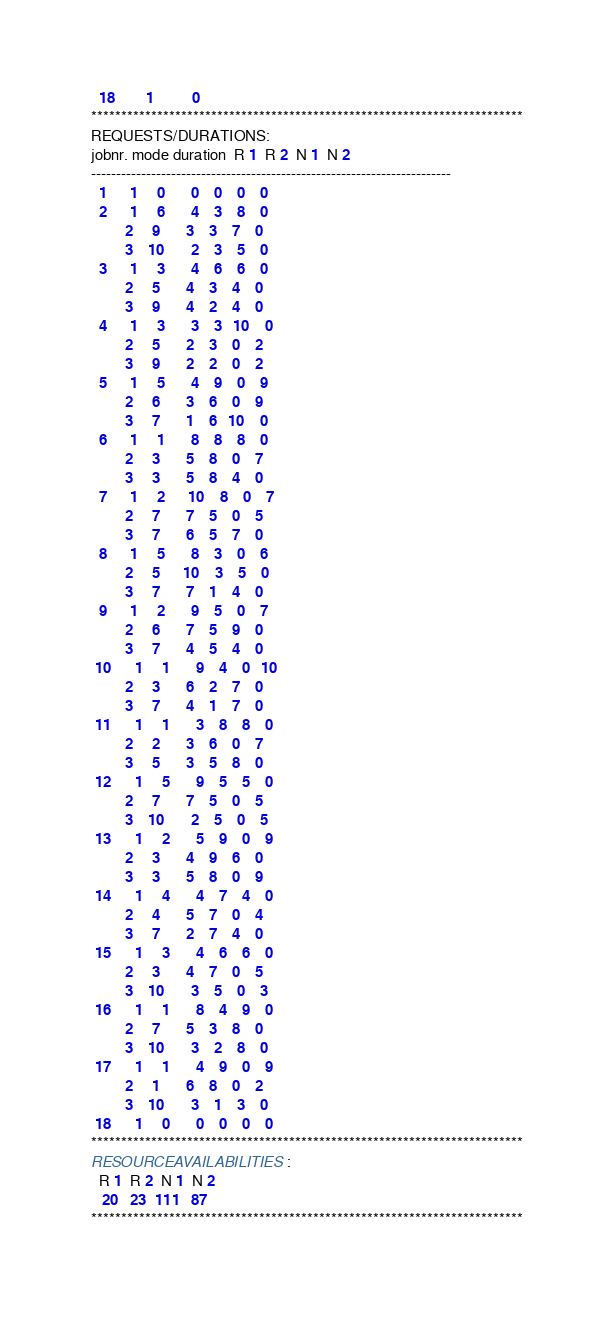Convert code to text. <code><loc_0><loc_0><loc_500><loc_500><_ObjectiveC_>  18        1          0        
************************************************************************
REQUESTS/DURATIONS:
jobnr. mode duration  R 1  R 2  N 1  N 2
------------------------------------------------------------------------
  1      1     0       0    0    0    0
  2      1     6       4    3    8    0
         2     9       3    3    7    0
         3    10       2    3    5    0
  3      1     3       4    6    6    0
         2     5       4    3    4    0
         3     9       4    2    4    0
  4      1     3       3    3   10    0
         2     5       2    3    0    2
         3     9       2    2    0    2
  5      1     5       4    9    0    9
         2     6       3    6    0    9
         3     7       1    6   10    0
  6      1     1       8    8    8    0
         2     3       5    8    0    7
         3     3       5    8    4    0
  7      1     2      10    8    0    7
         2     7       7    5    0    5
         3     7       6    5    7    0
  8      1     5       8    3    0    6
         2     5      10    3    5    0
         3     7       7    1    4    0
  9      1     2       9    5    0    7
         2     6       7    5    9    0
         3     7       4    5    4    0
 10      1     1       9    4    0   10
         2     3       6    2    7    0
         3     7       4    1    7    0
 11      1     1       3    8    8    0
         2     2       3    6    0    7
         3     5       3    5    8    0
 12      1     5       9    5    5    0
         2     7       7    5    0    5
         3    10       2    5    0    5
 13      1     2       5    9    0    9
         2     3       4    9    6    0
         3     3       5    8    0    9
 14      1     4       4    7    4    0
         2     4       5    7    0    4
         3     7       2    7    4    0
 15      1     3       4    6    6    0
         2     3       4    7    0    5
         3    10       3    5    0    3
 16      1     1       8    4    9    0
         2     7       5    3    8    0
         3    10       3    2    8    0
 17      1     1       4    9    0    9
         2     1       6    8    0    2
         3    10       3    1    3    0
 18      1     0       0    0    0    0
************************************************************************
RESOURCEAVAILABILITIES:
  R 1  R 2  N 1  N 2
   20   23  111   87
************************************************************************
</code> 